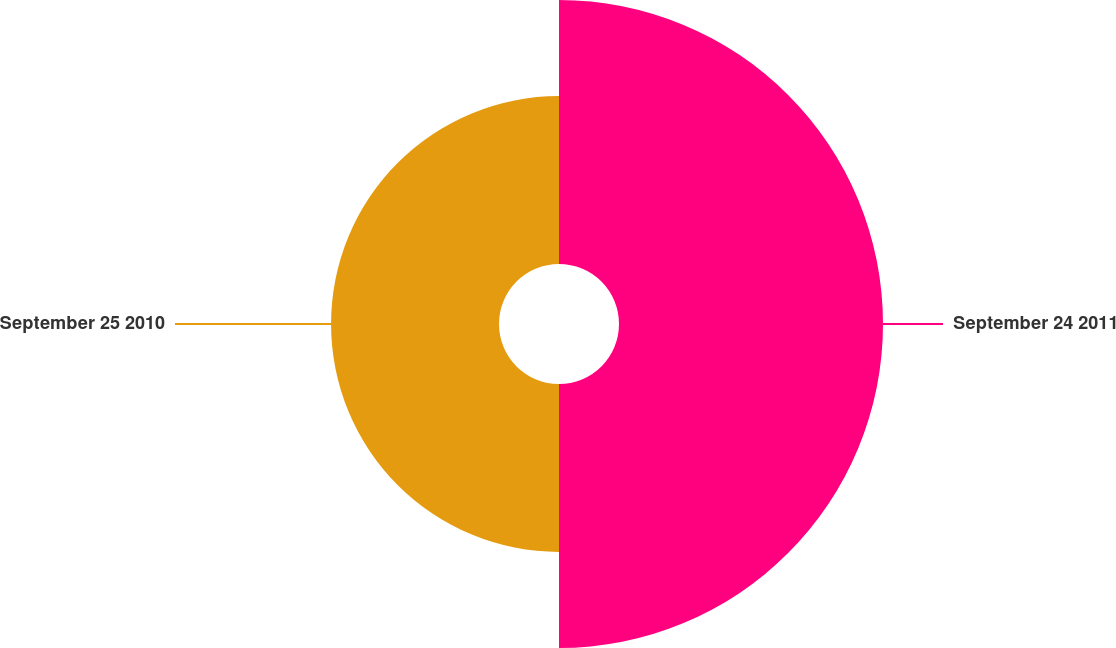Convert chart. <chart><loc_0><loc_0><loc_500><loc_500><pie_chart><fcel>September 24 2011<fcel>September 25 2010<nl><fcel>61.12%<fcel>38.88%<nl></chart> 